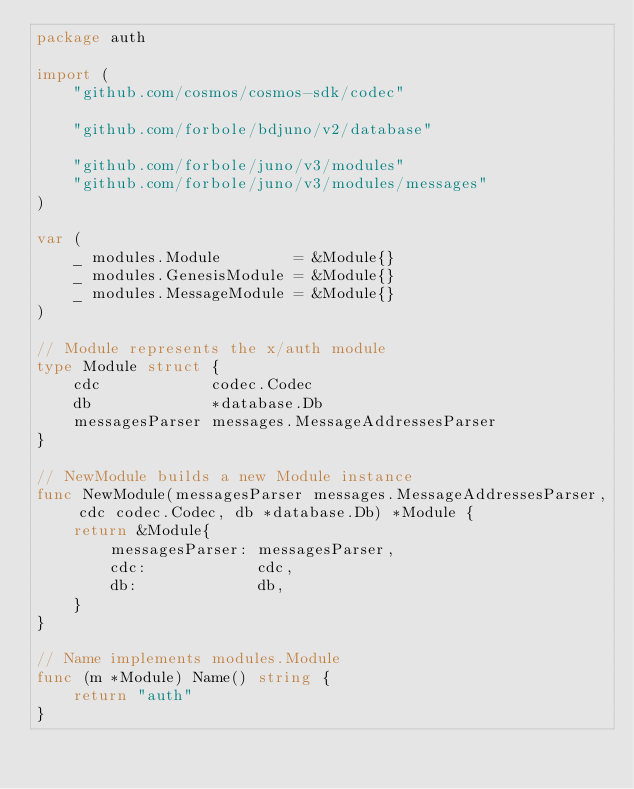Convert code to text. <code><loc_0><loc_0><loc_500><loc_500><_Go_>package auth

import (
	"github.com/cosmos/cosmos-sdk/codec"

	"github.com/forbole/bdjuno/v2/database"

	"github.com/forbole/juno/v3/modules"
	"github.com/forbole/juno/v3/modules/messages"
)

var (
	_ modules.Module        = &Module{}
	_ modules.GenesisModule = &Module{}
	_ modules.MessageModule = &Module{}
)

// Module represents the x/auth module
type Module struct {
	cdc            codec.Codec
	db             *database.Db
	messagesParser messages.MessageAddressesParser
}

// NewModule builds a new Module instance
func NewModule(messagesParser messages.MessageAddressesParser, cdc codec.Codec, db *database.Db) *Module {
	return &Module{
		messagesParser: messagesParser,
		cdc:            cdc,
		db:             db,
	}
}

// Name implements modules.Module
func (m *Module) Name() string {
	return "auth"
}
</code> 